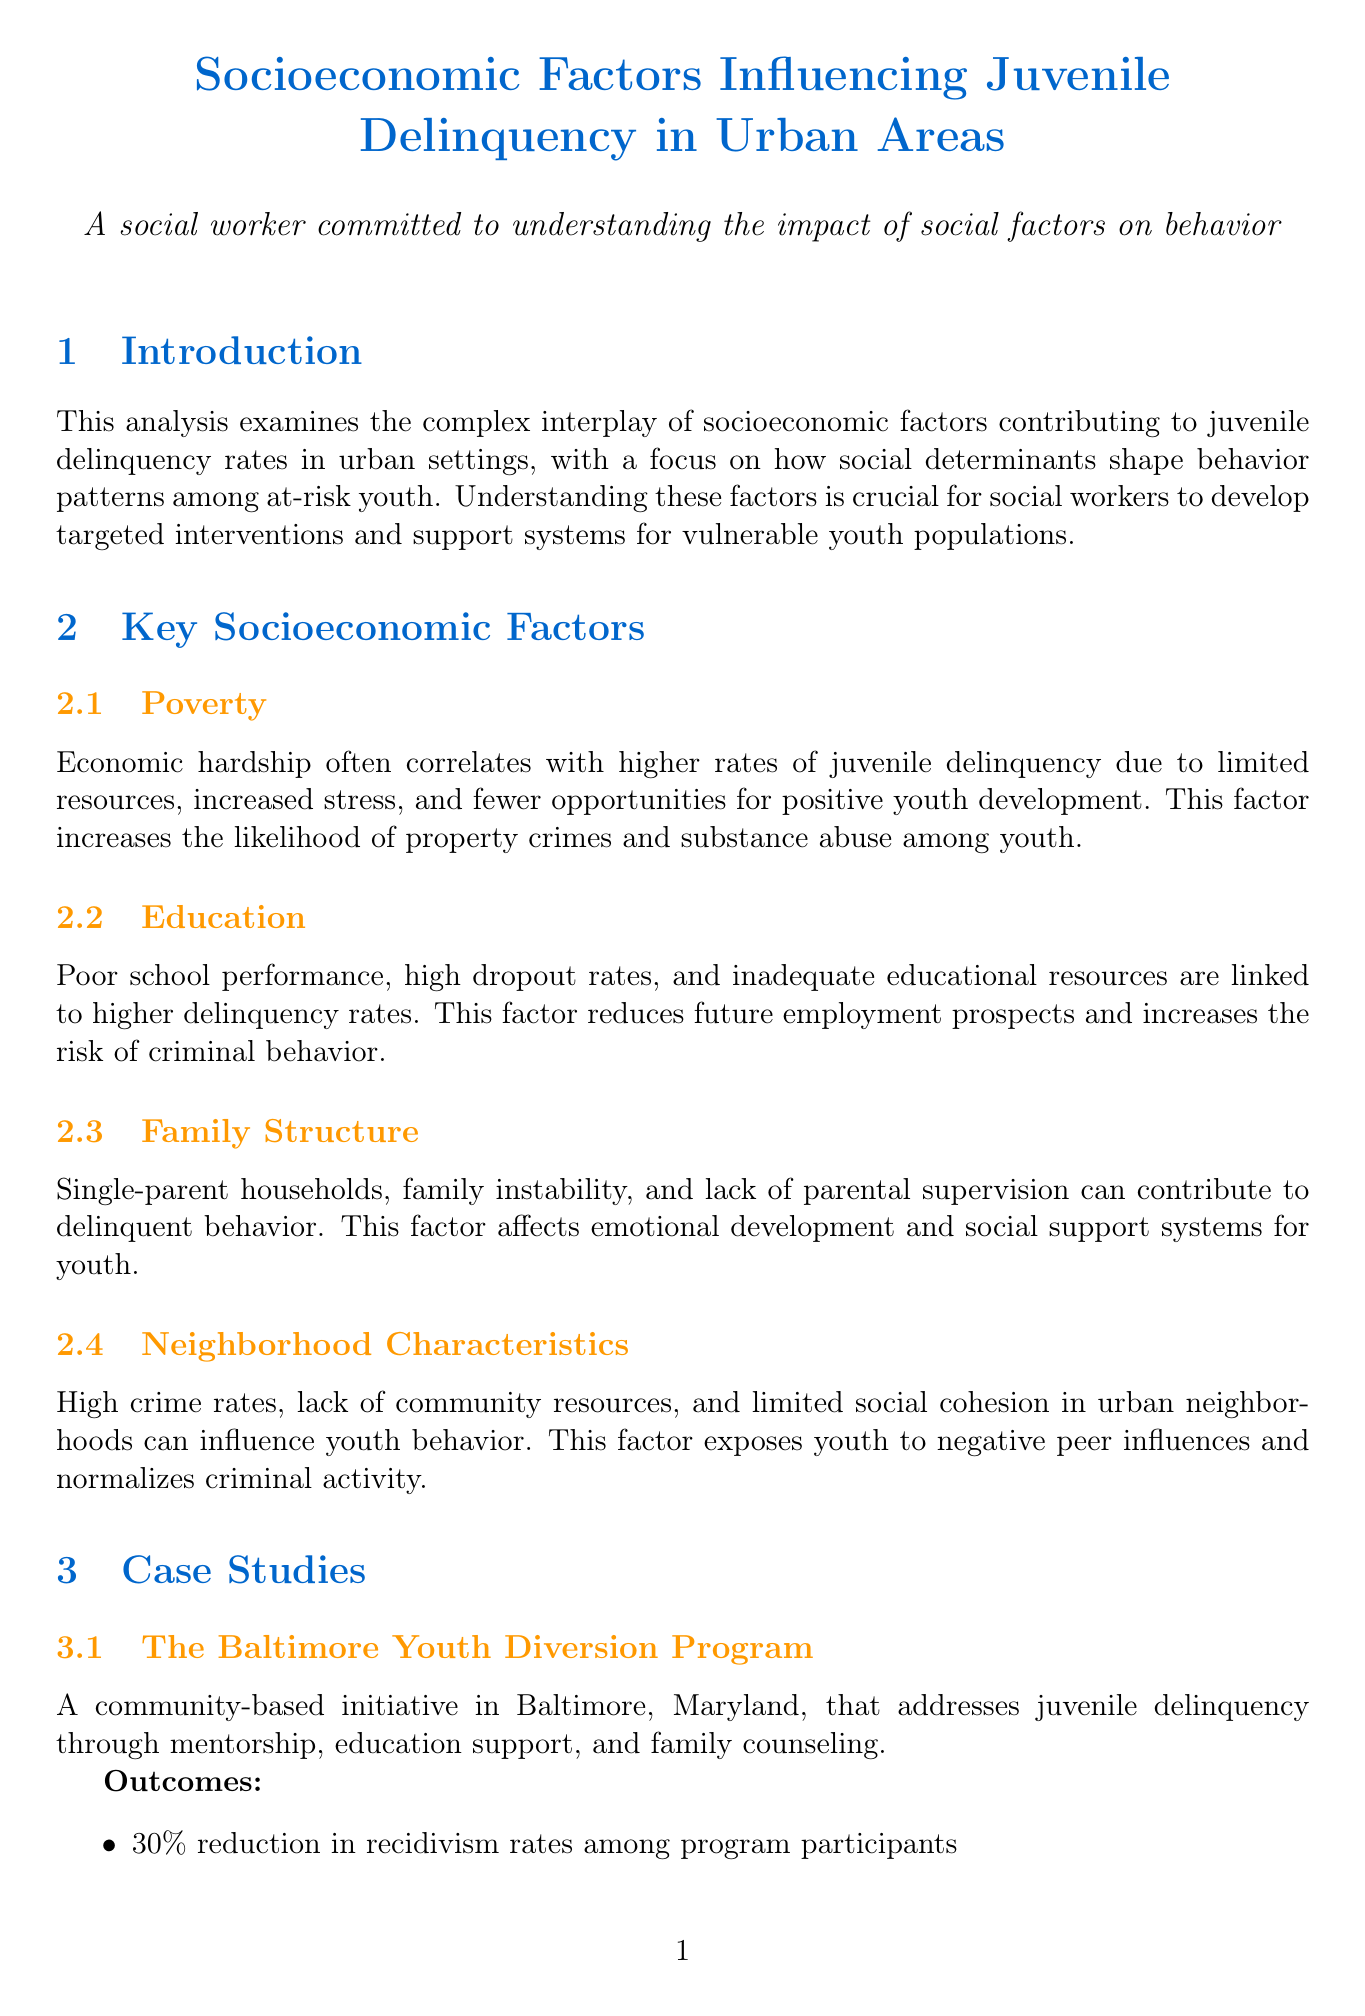What are the key socioeconomic factors influencing juvenile delinquency? The document lists four key socioeconomic factors: Poverty, Education, Family Structure, and Neighborhood Characteristics.
Answer: Poverty, Education, Family Structure, Neighborhood Characteristics What was the reduction in recidivism rates in the Baltimore Youth Diversion Program? The documented outcome states there was a 30% reduction in recidivism rates among program participants.
Answer: 30% Which city is associated with the Becoming A Man program? The document specifies that the Becoming A Man program is based in Chicago, Illinois.
Answer: Chicago What percentage of juvenile crime is attributed to dropouts according to the educational attainment pie chart? The pie chart in the document indicates that 45% of juvenile crime is from individuals who are dropouts.
Answer: 45% What recommendation is made regarding community development? The document recommends investing in urban renewal projects, community centers, and youth programs in disadvantaged neighborhoods.
Answer: Invest in urban renewal projects, community centers, and youth programs What is the expected impact of family support programs as mentioned in the policy implications? The document states that the expected impact is to strengthen family structures and improve parental supervision.
Answer: Strengthen family structures and improve parental supervision What type of chart illustrates juvenile delinquency rates by income level? The document describes a bar chart that illustrates juvenile delinquency rates categorized by income level.
Answer: Bar Chart What is the relevance of the Baltimore Youth Diversion Program? The document highlights its effectiveness in showing holistic, community-centered approaches in addressing socioeconomic factors contributing to delinquency.
Answer: Effectiveness of holistic, community-centered approaches 